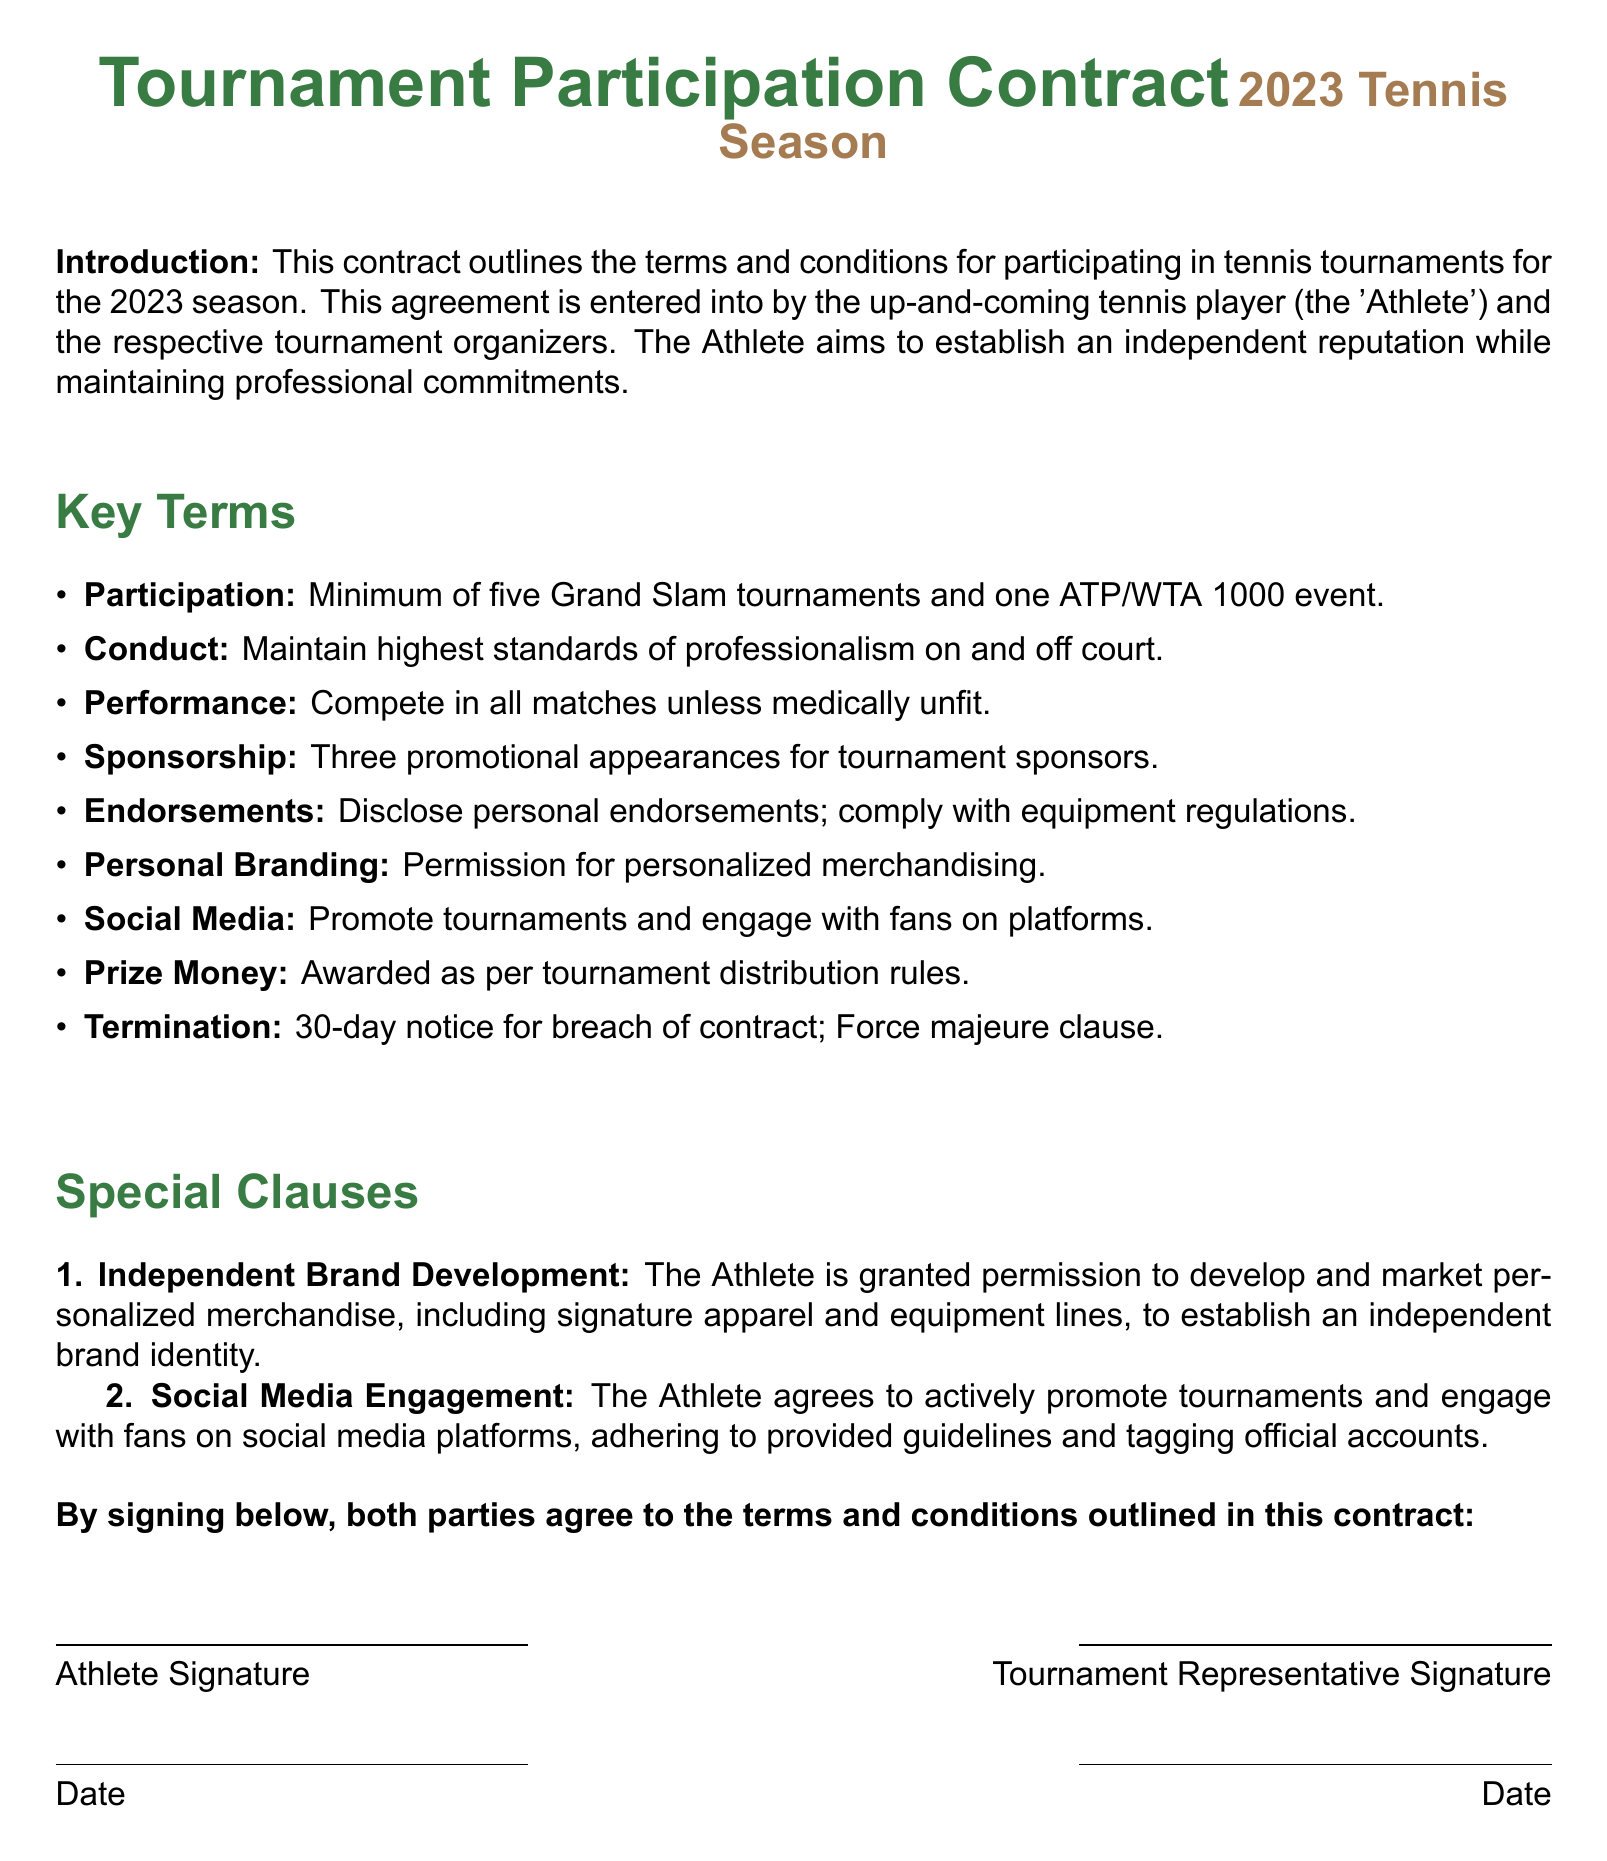What is the title of the document? The title is prominently displayed at the top of the document and indicates the nature of the contract.
Answer: Tournament Participation Contract How many Grand Slam tournaments must the Athlete participate in? The requirement for the Athlete's participation is specified clearly in the list of key terms.
Answer: Minimum of five What is the minimum ATP/WTA event the Athlete must compete in? The document specifies this requirement as part of the participation terms.
Answer: One ATP/WTA 1000 event What type of promotional appearances is the Athlete required to make? The specific type of appearances is mentioned under the sponsorship clause in the key terms.
Answer: Three promotional appearances What must the Athlete do regarding personal endorsements? The requirements concerning endorsements are listed in the key terms and attention is drawn to compliance.
Answer: Disclose personal endorsements What is the notice period for termination of the contract? The termination clause specifies the notice period that must be adhered to.
Answer: 30-day notice What does the Athlete agree to do on social media? The social media engagement clause outlines the Athlete's obligations regarding promotion and fan interaction.
Answer: Promote tournaments What is granted to the Athlete for independent brand development? The special clause clearly describes what permission is granted to the Athlete.
Answer: Permission to develop and market personalized merchandise What signifies agreement from both parties at the end of the document? The document includes a section where both parties sign to indicate their acceptance of the contract terms.
Answer: Signatures 